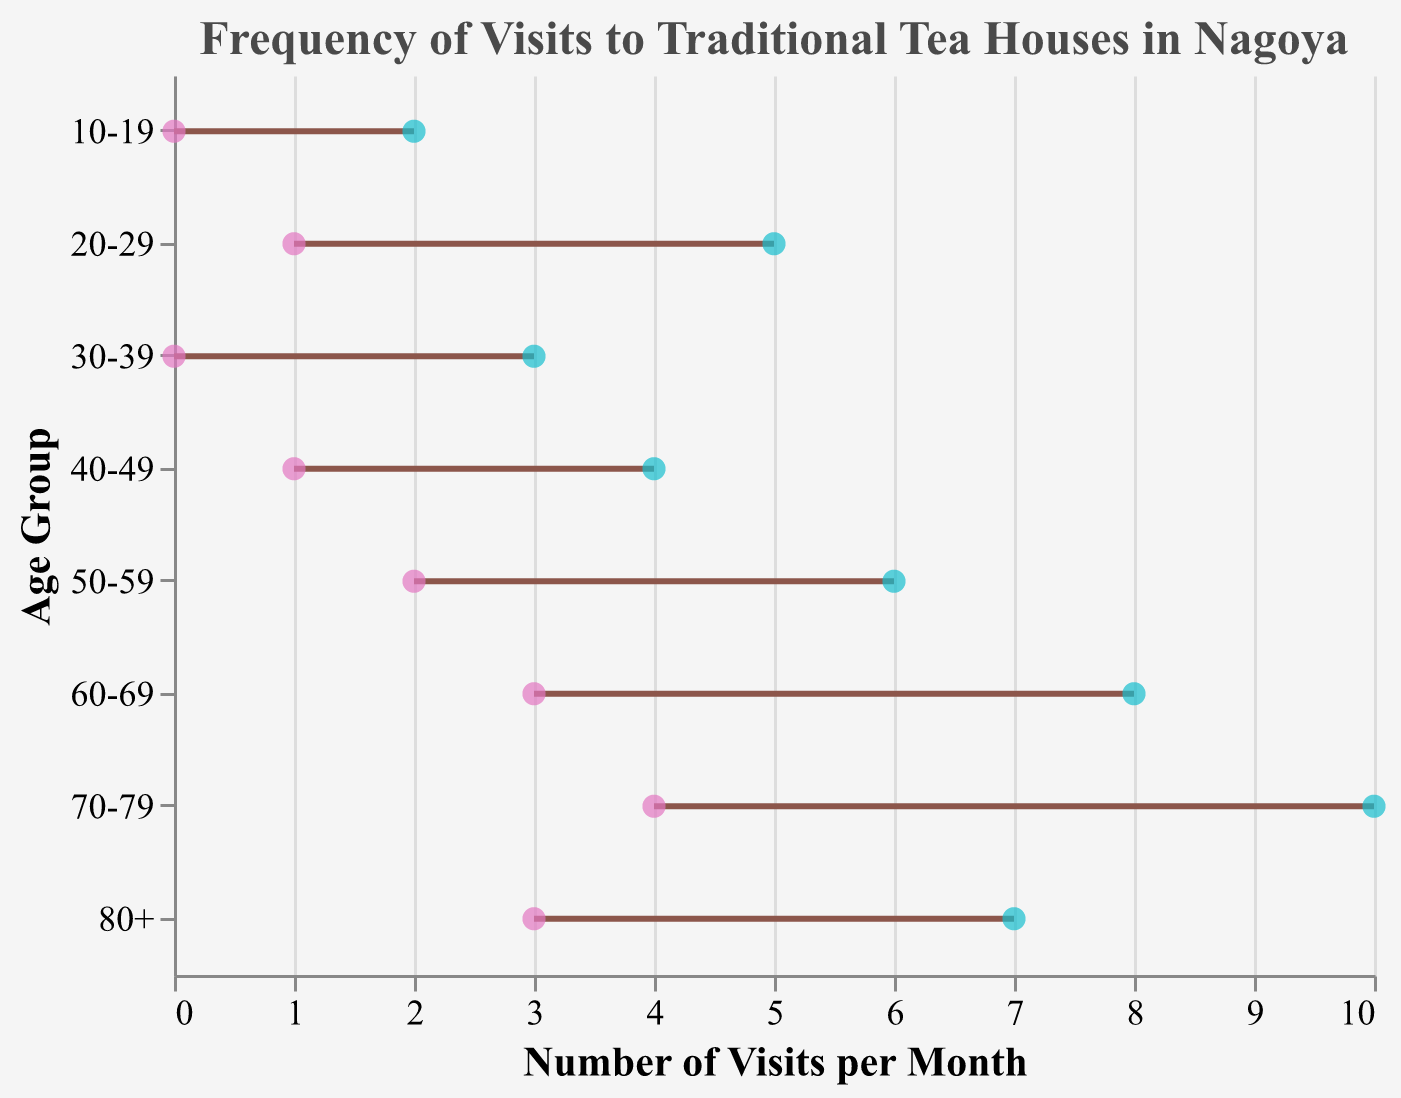What is the range of visits for the age group 70-79? The figure shows that the range of visits for the age group 70-79 is between the minimum and maximum values, which are represented by points connected by a line. Looking closely, the range for this age group is from 4 to 10 visits per month.
Answer: 4-10 Which age group visits the traditional tea houses the least? To determine which age group visits the tea houses the least, look for the group with the lowest minimum and maximum values. The age group 10-19 has the lowest range, with visits ranging from 0 to 2 per month.
Answer: 10-19 What is the maximum number of visits for the age group 50-59? The figure indicates the maximum number of visits for each age group using a colored point. For the age group 50-59, the maximum number of visits is represented by the point furthest to the right, which is 6 visits per month.
Answer: 6 Comparing the age groups 60-69 and 80+, which age group has a higher minimum number of visits? Comparing the minimum values for the two age groups on the x-axis, the age group 60-69 has a minimum of 3 visits per month, while the age group 80+ also has a minimum of 3 visits per month. Therefore, they have an equal minimum number of visits.
Answer: Equal How many age groups have their maximum visits per month exceeding 5? By counting the age groups where the maximum value point is greater than 5 on the x-axis, we see that the age groups 50-59 (max 6), 60-69 (max 8), and 70-79 (max 10), have maximum visits exceeding 5. Thus, there are 3 such age groups.
Answer: 3 What is the range of visits for the age group 30-39? The figure shows that the age group 30-39 has a range of visits spanning from the minimum point to the maximum point. For this group, the minimum is 0 visits and the maximum is 3 visits per month.
Answer: 0-3 Comparing the age groups 20-29 and 40-49, which has a wider range of visits? To compare ranges, subtract the minimum number of visits from the maximum for each group. The age group 20-29 ranges from 1 to 5 (4 visits), while the age group 40-49 ranges from 1 to 4 (3 visits). Thus, the age group 20-29 has a wider range of 4 visits.
Answer: 20-29 What is the average maximum number of visits among all age groups? To find the average maximum number of visits, add the maximum visits for all age groups and divide by the number of groups. The maximum values are 2, 5, 3, 4, 6, 8, 10, and 7. Summing these gives 45. Dividing by the 8 age groups, the average is 45 / 8 = 5.625.
Answer: 5.625 